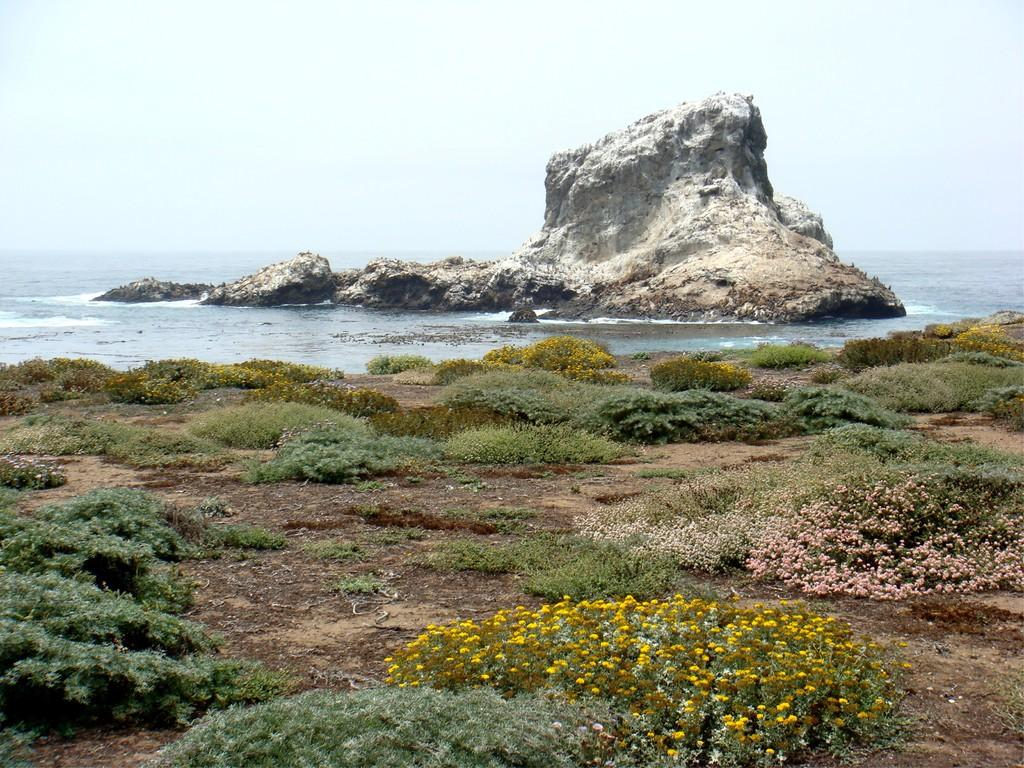What type of geological formation is present in the image? There is a stone mountain in the image. What natural feature is located near the mountain? There is an ocean in the image. What type of vegetation can be seen at the base of the mountain? Flowers, plants, and grass are visible at the bottom of the image. What is visible above the mountain and ocean? The sky is visible at the top of the image. What type of eggnog is being served at the beach in the image? There is no eggnog or beach present in the image; it features a stone mountain, an ocean, and vegetation. What games are being played at the top of the mountain in the image? There is no indication of games or play in the image; it only shows a stone mountain, an ocean, and vegetation. 